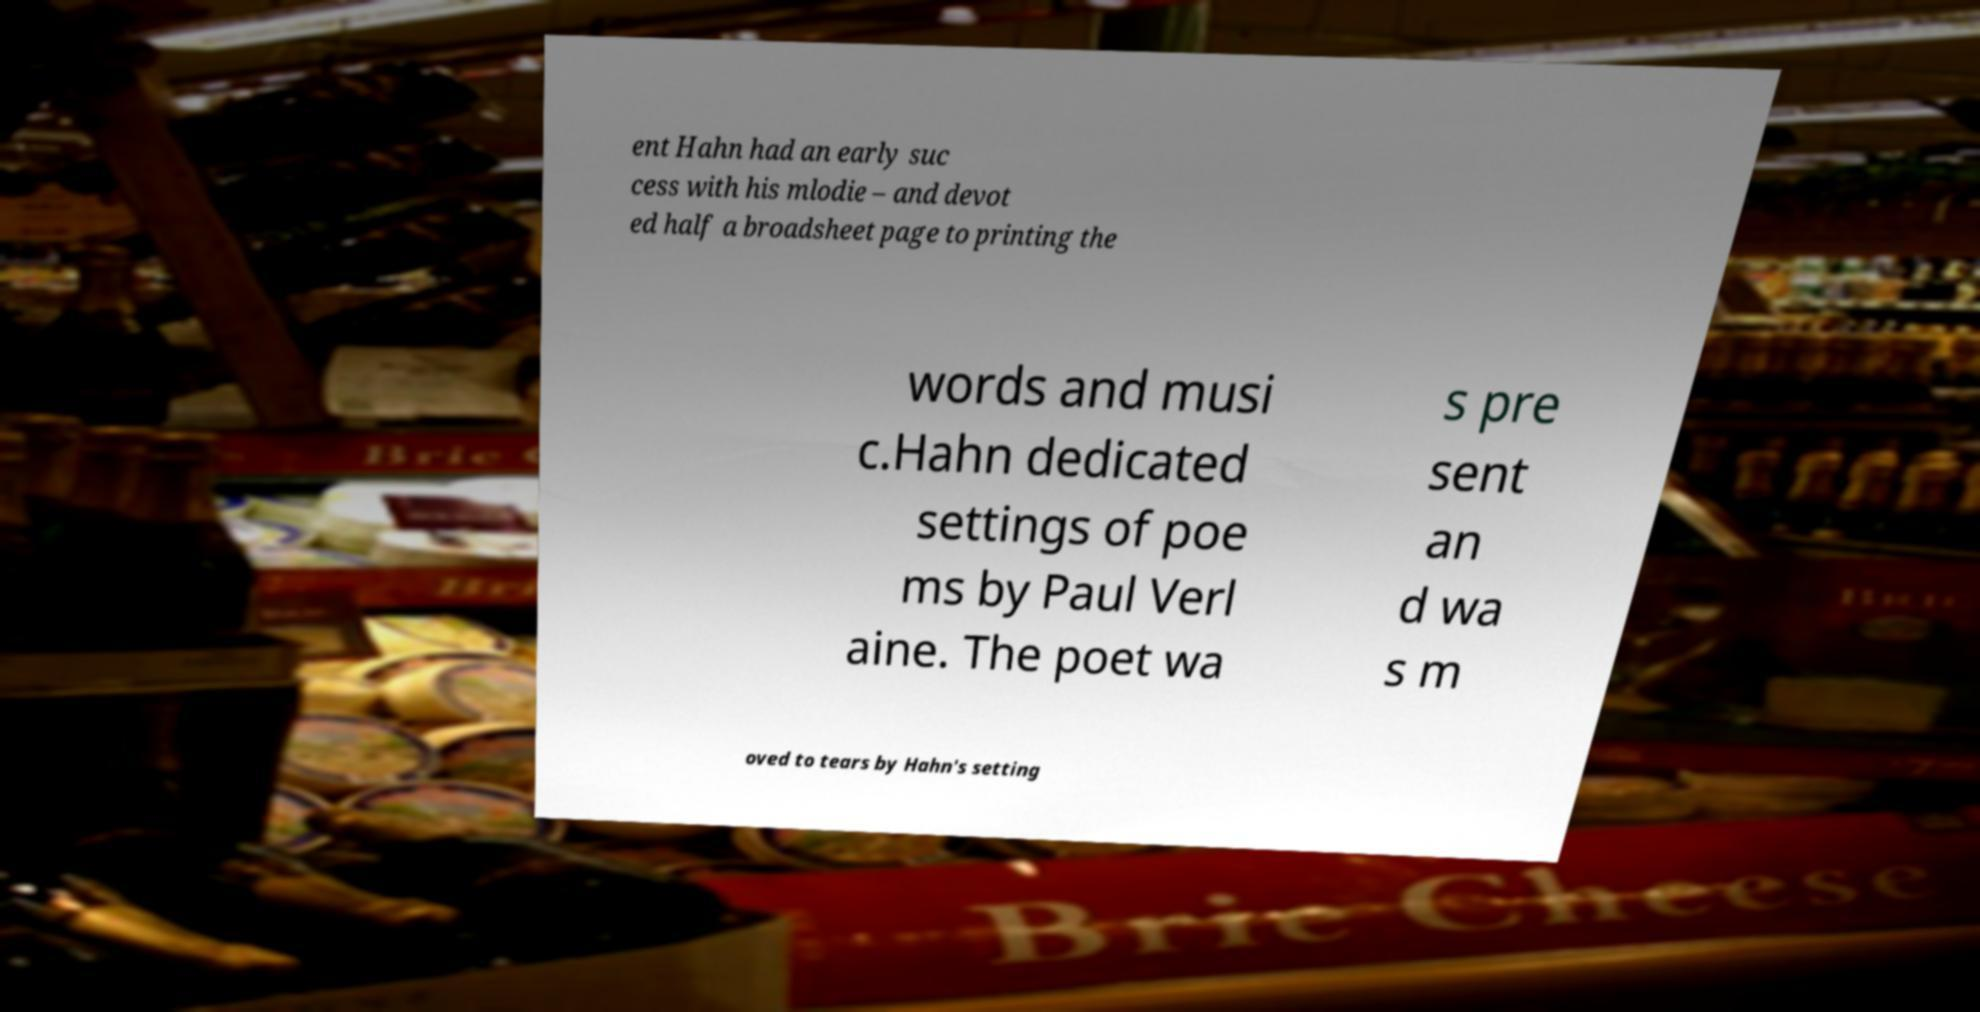Please identify and transcribe the text found in this image. ent Hahn had an early suc cess with his mlodie – and devot ed half a broadsheet page to printing the words and musi c.Hahn dedicated settings of poe ms by Paul Verl aine. The poet wa s pre sent an d wa s m oved to tears by Hahn's setting 